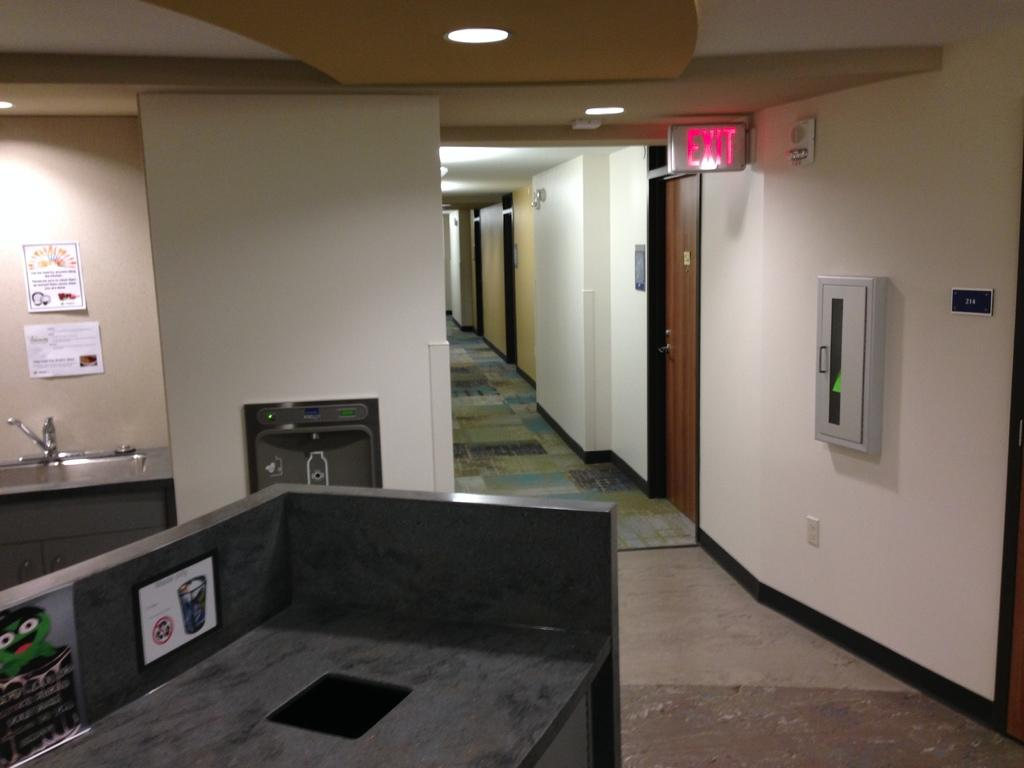<image>
Offer a succinct explanation of the picture presented. Building that contains room, a sink, counter, and exit sign 